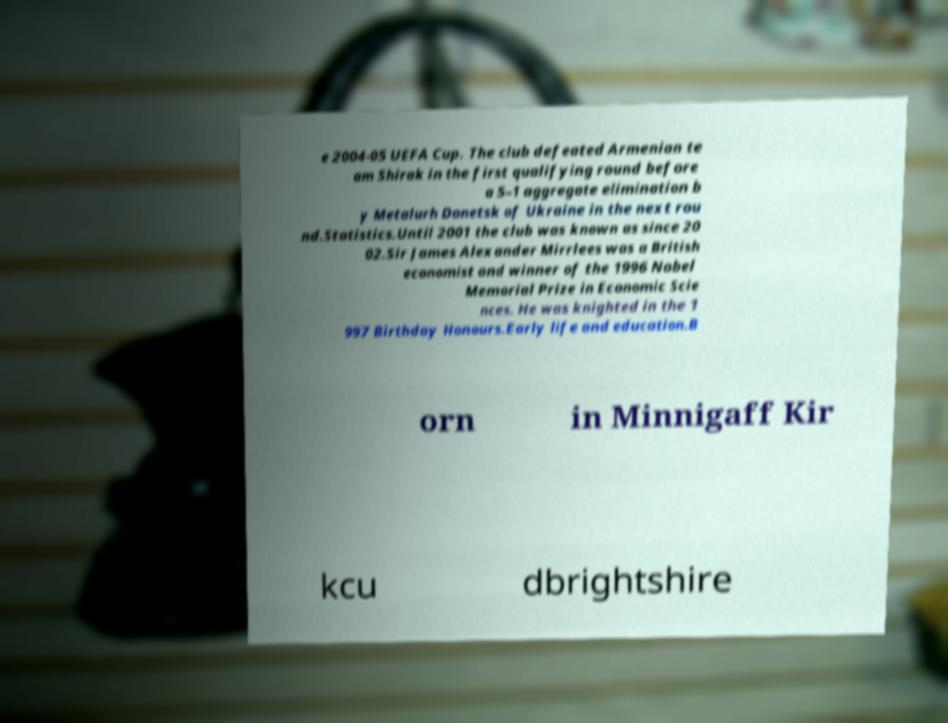Can you read and provide the text displayed in the image?This photo seems to have some interesting text. Can you extract and type it out for me? e 2004-05 UEFA Cup. The club defeated Armenian te am Shirak in the first qualifying round before a 5–1 aggregate elimination b y Metalurh Donetsk of Ukraine in the next rou nd.Statistics.Until 2001 the club was known as since 20 02.Sir James Alexander Mirrlees was a British economist and winner of the 1996 Nobel Memorial Prize in Economic Scie nces. He was knighted in the 1 997 Birthday Honours.Early life and education.B orn in Minnigaff Kir kcu dbrightshire 